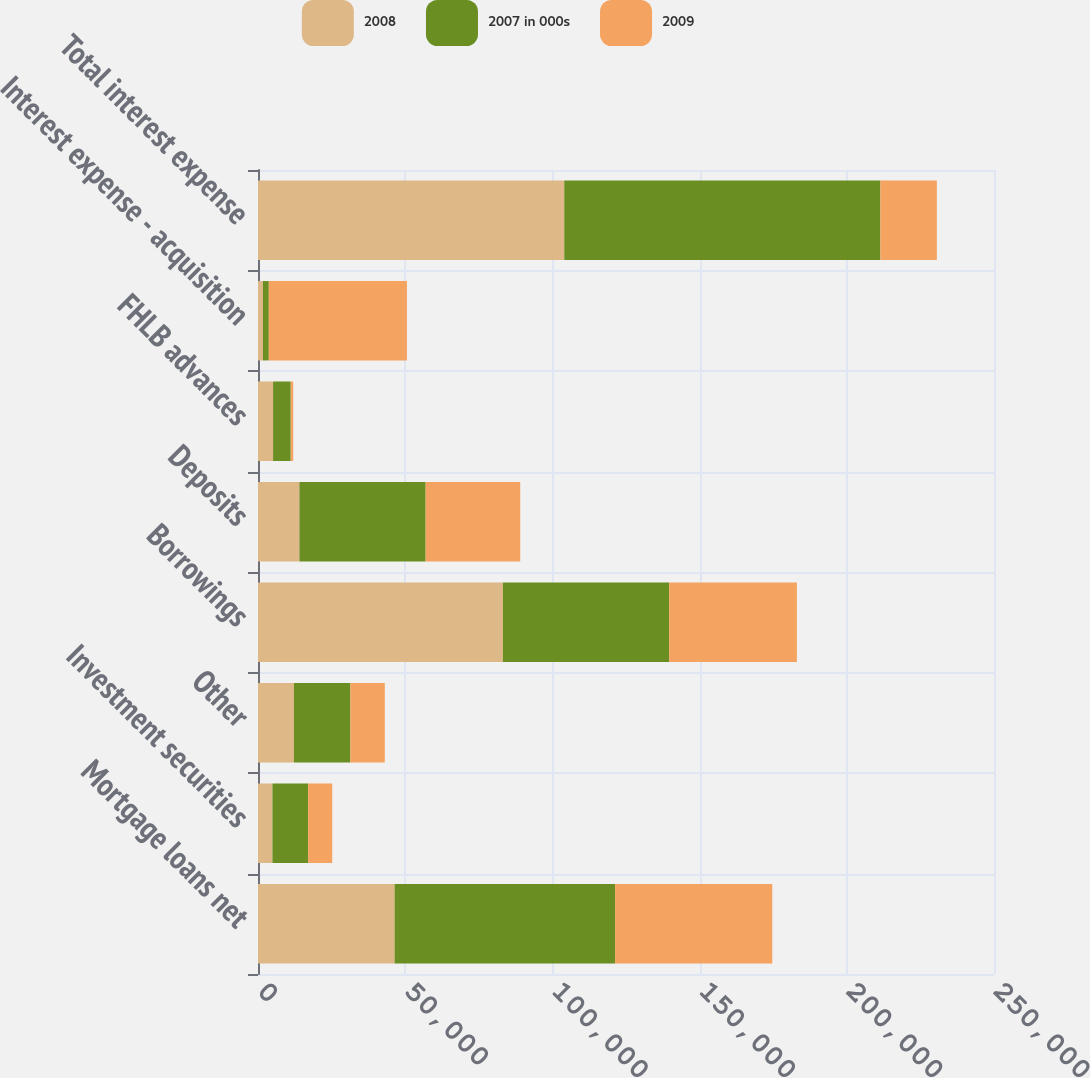Convert chart to OTSL. <chart><loc_0><loc_0><loc_500><loc_500><stacked_bar_chart><ecel><fcel>Mortgage loans net<fcel>Investment securities<fcel>Other<fcel>Borrowings<fcel>Deposits<fcel>FHLB advances<fcel>Interest expense - acquisition<fcel>Total interest expense<nl><fcel>2008<fcel>46396<fcel>4896<fcel>12205<fcel>83193<fcel>14069<fcel>5113<fcel>1653<fcel>104028<nl><fcel>2007 in 000s<fcel>74895<fcel>12143<fcel>19181<fcel>56482<fcel>42878<fcel>6008<fcel>2019<fcel>107387<nl><fcel>2009<fcel>53396<fcel>8174<fcel>11682<fcel>43378<fcel>32128<fcel>836<fcel>46920<fcel>19181<nl></chart> 